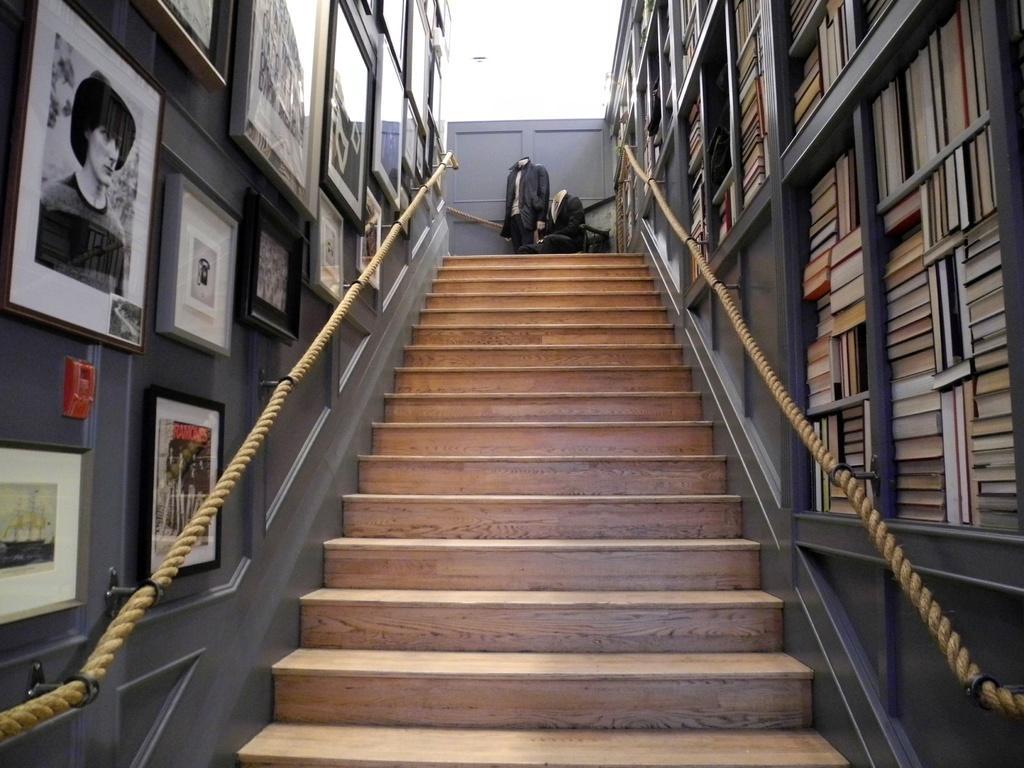Could you give a brief overview of what you see in this image? In this image we can see stairs. On the right side of the image, we can see books are arranged in shelves and a rope is present. On the left side of the image, we can see so many frames are attached to the wall and one rope is also attached. In the background, we can see two mannequins with black color dress. 